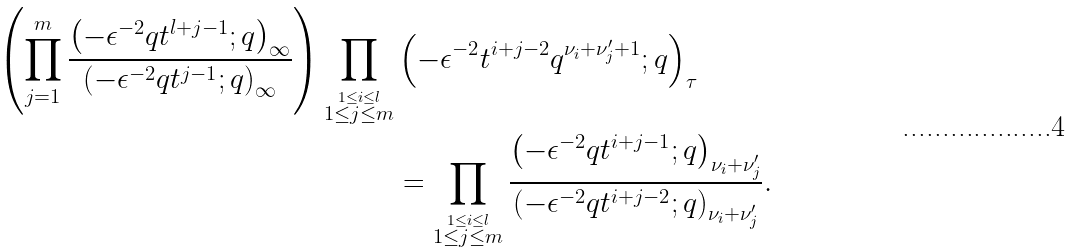<formula> <loc_0><loc_0><loc_500><loc_500>\left ( \prod _ { j = 1 } ^ { m } \frac { \left ( - \epsilon ^ { - 2 } q t ^ { l + j - 1 } ; q \right ) _ { \infty } } { \left ( - \epsilon ^ { - 2 } q t ^ { j - 1 } ; q \right ) _ { \infty } } \right ) \prod _ { \stackrel { 1 \leq i \leq l } { 1 \leq j \leq m } } & \left ( - \epsilon ^ { - 2 } t ^ { i + j - 2 } q ^ { \nu _ { i } + \nu _ { j } ^ { \prime } + 1 } ; q \right ) _ { \tau } \\ & = \prod _ { \stackrel { 1 \leq i \leq l } { 1 \leq j \leq m } } \frac { \left ( - \epsilon ^ { - 2 } q t ^ { i + j - 1 } ; q \right ) _ { \nu _ { i } + \nu _ { j } ^ { \prime } } } { \left ( - \epsilon ^ { - 2 } q t ^ { i + j - 2 } ; q \right ) _ { \nu _ { i } + \nu _ { j } ^ { \prime } } } . \\</formula> 